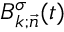Convert formula to latex. <formula><loc_0><loc_0><loc_500><loc_500>B _ { k ; \vec { n } } ^ { \sigma } ( t )</formula> 